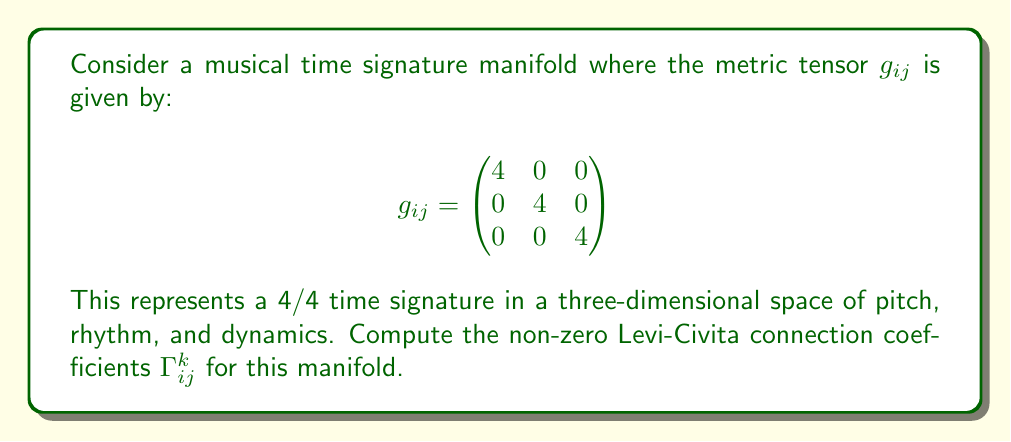Show me your answer to this math problem. To compute the Levi-Civita connection coefficients, we'll use the formula:

$$\Gamma^k_{ij} = \frac{1}{2}g^{kl}\left(\frac{\partial g_{jl}}{\partial x^i} + \frac{\partial g_{il}}{\partial x^j} - \frac{\partial g_{ij}}{\partial x^l}\right)$$

where $g^{kl}$ is the inverse metric tensor.

Step 1: Calculate the inverse metric tensor $g^{ij}$
Since the metric is diagonal, the inverse is simply:

$$g^{ij} = \begin{pmatrix}
1/4 & 0 & 0 \\
0 & 1/4 & 0 \\
0 & 0 & 1/4
\end{pmatrix}$$

Step 2: Calculate the partial derivatives
All partial derivatives of $g_{ij}$ with respect to $x^k$ are zero because the metric components are constants.

Step 3: Apply the formula
Since all partial derivatives are zero, we have:

$$\Gamma^k_{ij} = \frac{1}{2}g^{kl}(0 + 0 - 0) = 0$$

for all $i$, $j$, and $k$.

Step 4: Interpret the result
In the context of our musical time signature manifold, this means that the manifold is flat and there is no curvature in the space of pitch, rhythm, and dynamics for a 4/4 time signature. This aligns with the intuition that a constant time signature doesn't introduce any "bending" in our musical space.
Answer: $\Gamma^k_{ij} = 0$ for all $i$, $j$, and $k$. 